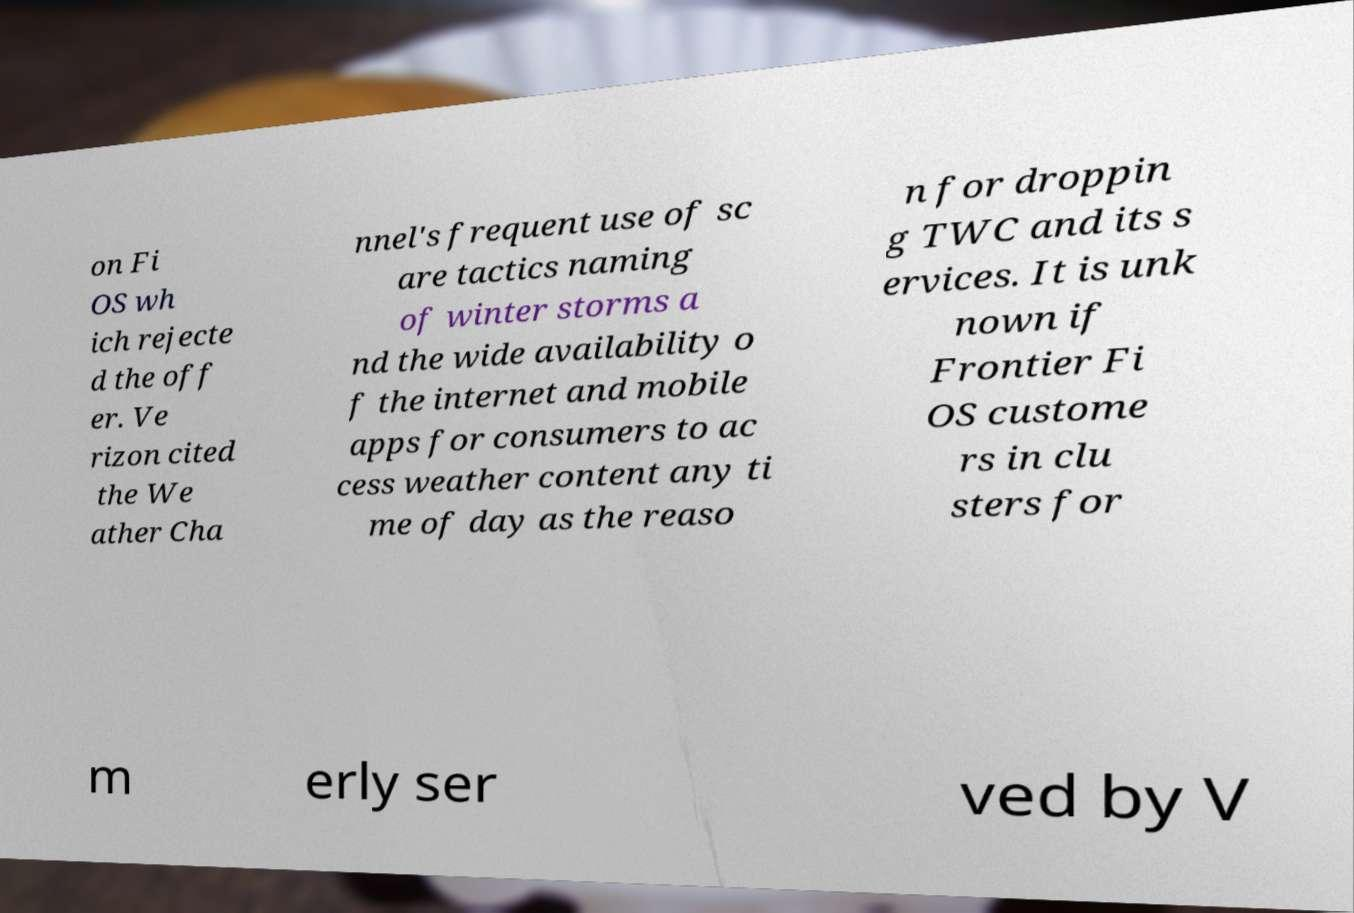Could you assist in decoding the text presented in this image and type it out clearly? on Fi OS wh ich rejecte d the off er. Ve rizon cited the We ather Cha nnel's frequent use of sc are tactics naming of winter storms a nd the wide availability o f the internet and mobile apps for consumers to ac cess weather content any ti me of day as the reaso n for droppin g TWC and its s ervices. It is unk nown if Frontier Fi OS custome rs in clu sters for m erly ser ved by V 